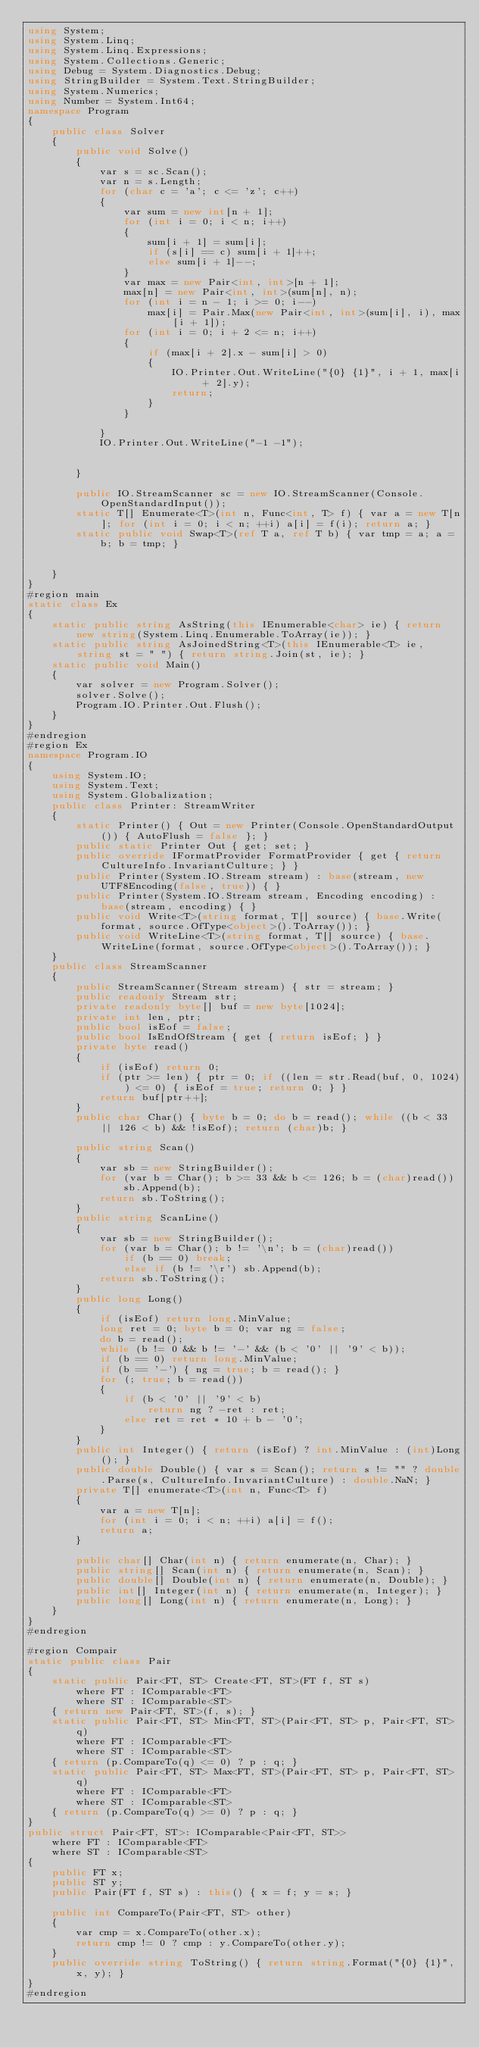Convert code to text. <code><loc_0><loc_0><loc_500><loc_500><_C#_>using System;
using System.Linq;
using System.Linq.Expressions;
using System.Collections.Generic;
using Debug = System.Diagnostics.Debug;
using StringBuilder = System.Text.StringBuilder;
using System.Numerics;
using Number = System.Int64;
namespace Program
{
    public class Solver
    {
        public void Solve()
        {
            var s = sc.Scan();
            var n = s.Length;
            for (char c = 'a'; c <= 'z'; c++)
            {
                var sum = new int[n + 1];
                for (int i = 0; i < n; i++)
                {
                    sum[i + 1] = sum[i];
                    if (s[i] == c) sum[i + 1]++;
                    else sum[i + 1]--;
                }
                var max = new Pair<int, int>[n + 1];
                max[n] = new Pair<int, int>(sum[n], n);
                for (int i = n - 1; i >= 0; i--)
                    max[i] = Pair.Max(new Pair<int, int>(sum[i], i), max[i + 1]);
                for (int i = 0; i + 2 <= n; i++)
                {
                    if (max[i + 2].x - sum[i] > 0)
                    {
                        IO.Printer.Out.WriteLine("{0} {1}", i + 1, max[i + 2].y);
                        return;
                    }
                }

            }
            IO.Printer.Out.WriteLine("-1 -1");


        }

        public IO.StreamScanner sc = new IO.StreamScanner(Console.OpenStandardInput());
        static T[] Enumerate<T>(int n, Func<int, T> f) { var a = new T[n]; for (int i = 0; i < n; ++i) a[i] = f(i); return a; }
        static public void Swap<T>(ref T a, ref T b) { var tmp = a; a = b; b = tmp; }


    }
}
#region main
static class Ex
{
    static public string AsString(this IEnumerable<char> ie) { return new string(System.Linq.Enumerable.ToArray(ie)); }
    static public string AsJoinedString<T>(this IEnumerable<T> ie, string st = " ") { return string.Join(st, ie); }
    static public void Main()
    {
        var solver = new Program.Solver();
        solver.Solve();
        Program.IO.Printer.Out.Flush();
    }
}
#endregion
#region Ex
namespace Program.IO
{
    using System.IO;
    using System.Text;
    using System.Globalization;
    public class Printer: StreamWriter
    {
        static Printer() { Out = new Printer(Console.OpenStandardOutput()) { AutoFlush = false }; }
        public static Printer Out { get; set; }
        public override IFormatProvider FormatProvider { get { return CultureInfo.InvariantCulture; } }
        public Printer(System.IO.Stream stream) : base(stream, new UTF8Encoding(false, true)) { }
        public Printer(System.IO.Stream stream, Encoding encoding) : base(stream, encoding) { }
        public void Write<T>(string format, T[] source) { base.Write(format, source.OfType<object>().ToArray()); }
        public void WriteLine<T>(string format, T[] source) { base.WriteLine(format, source.OfType<object>().ToArray()); }
    }
    public class StreamScanner
    {
        public StreamScanner(Stream stream) { str = stream; }
        public readonly Stream str;
        private readonly byte[] buf = new byte[1024];
        private int len, ptr;
        public bool isEof = false;
        public bool IsEndOfStream { get { return isEof; } }
        private byte read()
        {
            if (isEof) return 0;
            if (ptr >= len) { ptr = 0; if ((len = str.Read(buf, 0, 1024)) <= 0) { isEof = true; return 0; } }
            return buf[ptr++];
        }
        public char Char() { byte b = 0; do b = read(); while ((b < 33 || 126 < b) && !isEof); return (char)b; }

        public string Scan()
        {
            var sb = new StringBuilder();
            for (var b = Char(); b >= 33 && b <= 126; b = (char)read())
                sb.Append(b);
            return sb.ToString();
        }
        public string ScanLine()
        {
            var sb = new StringBuilder();
            for (var b = Char(); b != '\n'; b = (char)read())
                if (b == 0) break;
                else if (b != '\r') sb.Append(b);
            return sb.ToString();
        }
        public long Long()
        {
            if (isEof) return long.MinValue;
            long ret = 0; byte b = 0; var ng = false;
            do b = read();
            while (b != 0 && b != '-' && (b < '0' || '9' < b));
            if (b == 0) return long.MinValue;
            if (b == '-') { ng = true; b = read(); }
            for (; true; b = read())
            {
                if (b < '0' || '9' < b)
                    return ng ? -ret : ret;
                else ret = ret * 10 + b - '0';
            }
        }
        public int Integer() { return (isEof) ? int.MinValue : (int)Long(); }
        public double Double() { var s = Scan(); return s != "" ? double.Parse(s, CultureInfo.InvariantCulture) : double.NaN; }
        private T[] enumerate<T>(int n, Func<T> f)
        {
            var a = new T[n];
            for (int i = 0; i < n; ++i) a[i] = f();
            return a;
        }

        public char[] Char(int n) { return enumerate(n, Char); }
        public string[] Scan(int n) { return enumerate(n, Scan); }
        public double[] Double(int n) { return enumerate(n, Double); }
        public int[] Integer(int n) { return enumerate(n, Integer); }
        public long[] Long(int n) { return enumerate(n, Long); }
    }
}
#endregion

#region Compair
static public class Pair
{
    static public Pair<FT, ST> Create<FT, ST>(FT f, ST s)
        where FT : IComparable<FT>
        where ST : IComparable<ST>
    { return new Pair<FT, ST>(f, s); }
    static public Pair<FT, ST> Min<FT, ST>(Pair<FT, ST> p, Pair<FT, ST> q)
        where FT : IComparable<FT>
        where ST : IComparable<ST>
    { return (p.CompareTo(q) <= 0) ? p : q; }
    static public Pair<FT, ST> Max<FT, ST>(Pair<FT, ST> p, Pair<FT, ST> q)
        where FT : IComparable<FT>
        where ST : IComparable<ST>
    { return (p.CompareTo(q) >= 0) ? p : q; }
}
public struct Pair<FT, ST>: IComparable<Pair<FT, ST>>
    where FT : IComparable<FT>
    where ST : IComparable<ST>
{
    public FT x;
    public ST y;
    public Pair(FT f, ST s) : this() { x = f; y = s; }

    public int CompareTo(Pair<FT, ST> other)
    {
        var cmp = x.CompareTo(other.x);
        return cmp != 0 ? cmp : y.CompareTo(other.y);
    }
    public override string ToString() { return string.Format("{0} {1}", x, y); }
}
#endregion</code> 